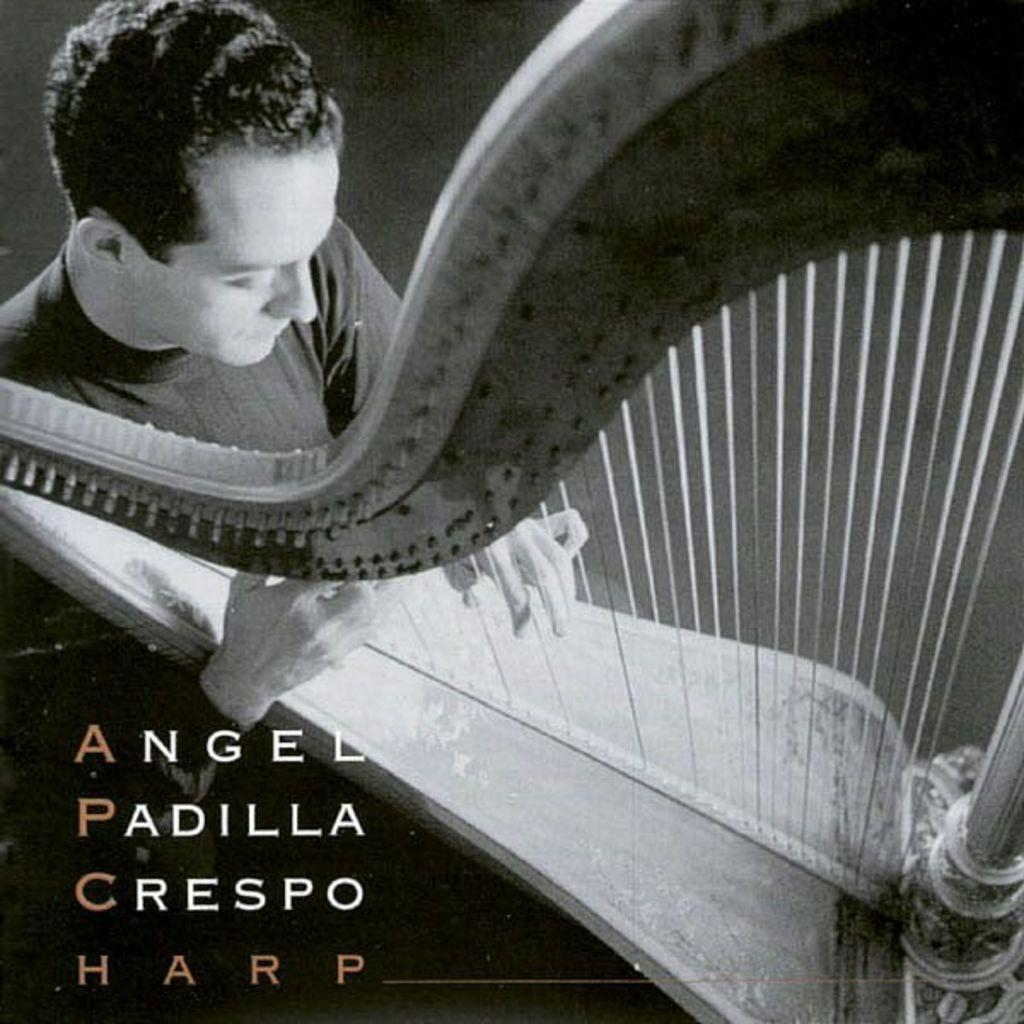What is the color scheme of the image? The image is black and white. What is the person in the image doing? The person is playing a musical instrument in the image. Is there any text present in the image? Yes, there is some text in the image. Can you see a boy playing with a duck in the park in the image? There is no boy playing with a duck in the park in the image, as it is black and white and only features a person playing a musical instrument and some text. 